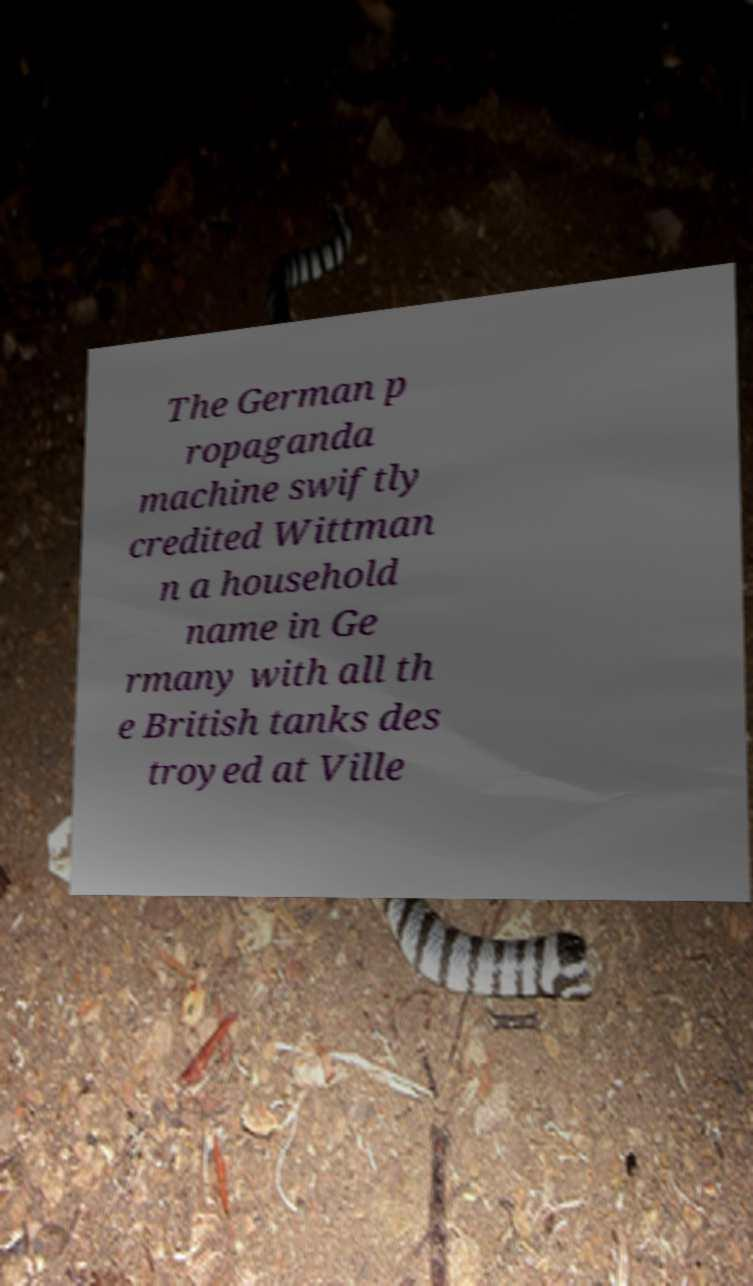Can you accurately transcribe the text from the provided image for me? The German p ropaganda machine swiftly credited Wittman n a household name in Ge rmany with all th e British tanks des troyed at Ville 